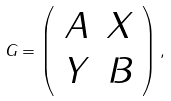<formula> <loc_0><loc_0><loc_500><loc_500>G = \left ( \begin{array} { c c } A & X \\ Y & B \end{array} \right ) ,</formula> 